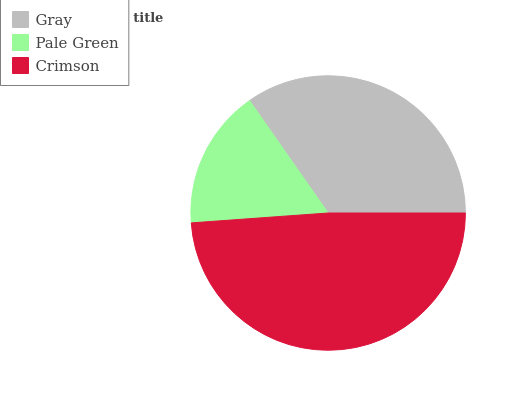Is Pale Green the minimum?
Answer yes or no. Yes. Is Crimson the maximum?
Answer yes or no. Yes. Is Crimson the minimum?
Answer yes or no. No. Is Pale Green the maximum?
Answer yes or no. No. Is Crimson greater than Pale Green?
Answer yes or no. Yes. Is Pale Green less than Crimson?
Answer yes or no. Yes. Is Pale Green greater than Crimson?
Answer yes or no. No. Is Crimson less than Pale Green?
Answer yes or no. No. Is Gray the high median?
Answer yes or no. Yes. Is Gray the low median?
Answer yes or no. Yes. Is Pale Green the high median?
Answer yes or no. No. Is Crimson the low median?
Answer yes or no. No. 